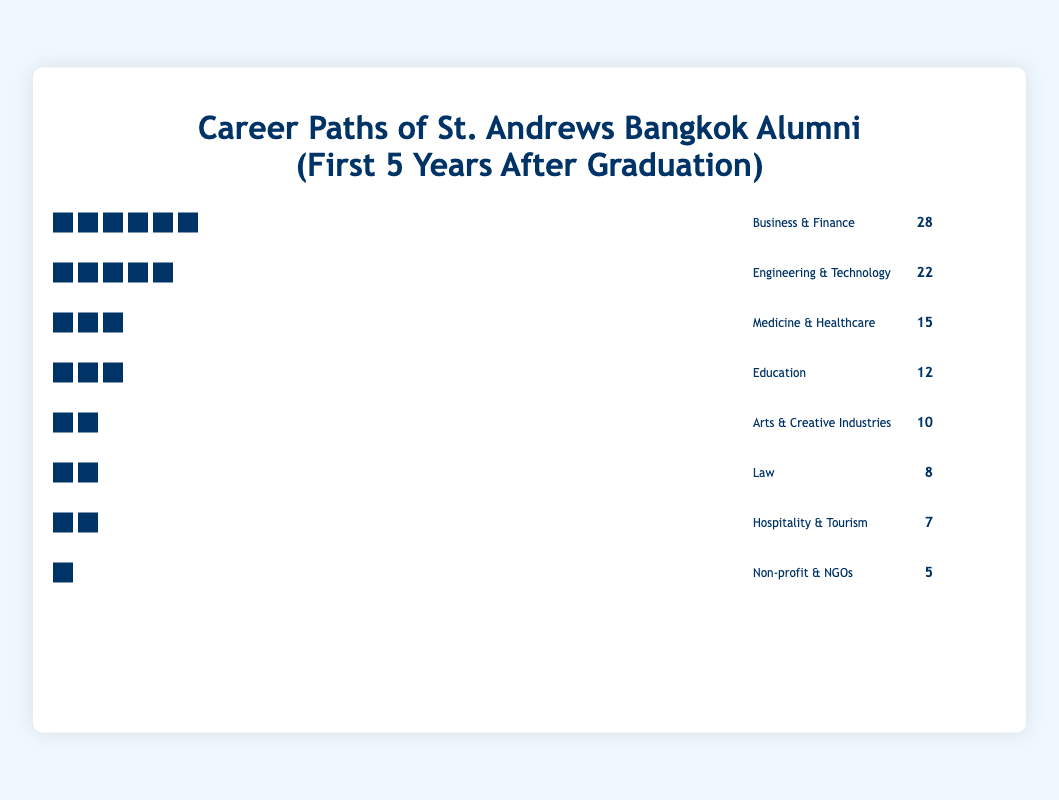What is the most common career path chosen by St. Andrews Bangkok alumni in the first five years after graduation? The most common career path can be identified by looking for the tallest row of icons, which corresponds to the highest count. "Business & Finance" has 28 icons, making it the most common career path.
Answer: Business & Finance Which career path has the least number of alumni? To find the least common career path, look for the shortest row of icons. The "Non-profit & NGOs" section has the least number of icons, with only 5 alumni.
Answer: Non-profit & NGOs How many more alumni chose Engineering & Technology over Law? To solve this, find the difference in the count of alumni between these two career paths. Engineering & Technology has 22, while Law has 8. The difference is 22 - 8 = 14.
Answer: 14 What is the total number of alumni represented in the figure? Add up the counts from all the career paths: 28 (Business & Finance) + 22 (Engineering & Technology) + 15 (Medicine & Healthcare) + 12 (Education) + 10 (Arts & Creative Industries) + 8 (Law) + 7 (Hospitality & Tourism) + 5 (Non-profit & NGOs). The total is 107.
Answer: 107 Which career path has double the number of alumni compared to Non-profit & NGOs? Non-profit & NGOs have 5 alumni. Double that number is 10. The "Arts & Creative Industries" with 10 alumni fits this criterion.
Answer: Arts & Creative Industries What is the combined count of alumni in Medicine & Healthcare and Education? To find the combined count, add the number of alumni in both career paths. Medicine & Healthcare has 15, and Education has 12. Their combined count is 15 + 12 = 27.
Answer: 27 Rank the career paths from most to least popular. To determine the ranks, order the career paths by the number of alumni in descending order: 1. Business & Finance (28), 2. Engineering & Technology (22), 3. Medicine & Healthcare (15), 4. Education (12), 5. Arts & Creative Industries (10), 6. Law (8), 7. Hospitality & Tourism (7), 8. Non-profit & NGOs (5).
Answer: Business & Finance, Engineering & Technology, Medicine & Healthcare, Education, Arts & Creative Industries, Law, Hospitality & Tourism, Non-profit & NGOs How many career paths have more than 10 alumni? Count the number of career paths where the count of alumni is greater than 10. The paths are Business & Finance (28), Engineering & Technology (22), Medicine & Healthcare (15), and Education (12). This gives 4 career paths.
Answer: 4 Which career paths have a count that is a multiple of 7? To identify the career paths where the count is a multiple of 7, observe the data: Business & Finance (28), Engineering & Technology (22), Medicine & Healthcare (15), Education (12), Arts & Creative Industries (10), Law (8), Hospitality & Tourism (7), and Non-Profit & NGOs (5). The multiples of 7 are 28 and 7. Therefore, the career paths are Business & Finance and Hospitality & Tourism.
Answer: Business & Finance, Hospitality & Tourism Which career path has an alumni count that is closer to the average number of alumni per career path? To find the average count, divide the total number of alumni (107) by the number of career paths (8). The average is 107 / 8 = 13.375. Comparing this to the counts, "Education" with 12 alumni is closest to the average.
Answer: Education 